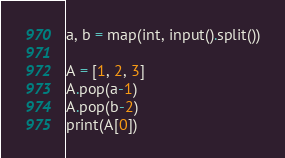Convert code to text. <code><loc_0><loc_0><loc_500><loc_500><_Python_>a, b = map(int, input().split())

A = [1, 2, 3]
A.pop(a-1)
A.pop(b-2)
print(A[0])</code> 